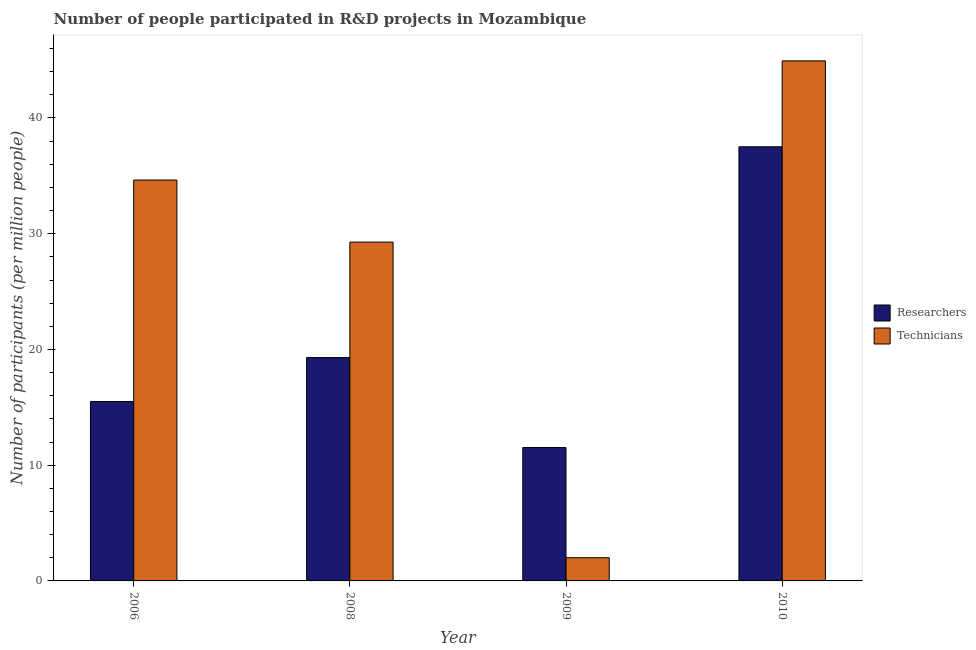How many groups of bars are there?
Offer a very short reply. 4. How many bars are there on the 4th tick from the left?
Ensure brevity in your answer.  2. How many bars are there on the 1st tick from the right?
Your answer should be very brief. 2. In how many cases, is the number of bars for a given year not equal to the number of legend labels?
Your answer should be very brief. 0. What is the number of researchers in 2009?
Offer a terse response. 11.53. Across all years, what is the maximum number of researchers?
Offer a very short reply. 37.51. Across all years, what is the minimum number of researchers?
Make the answer very short. 11.53. In which year was the number of technicians minimum?
Provide a short and direct response. 2009. What is the total number of researchers in the graph?
Ensure brevity in your answer.  83.84. What is the difference between the number of technicians in 2008 and that in 2010?
Give a very brief answer. -15.66. What is the difference between the number of technicians in 2010 and the number of researchers in 2009?
Provide a short and direct response. 42.93. What is the average number of technicians per year?
Your response must be concise. 27.71. In how many years, is the number of technicians greater than 30?
Your answer should be compact. 2. What is the ratio of the number of technicians in 2006 to that in 2008?
Your answer should be compact. 1.18. Is the difference between the number of researchers in 2009 and 2010 greater than the difference between the number of technicians in 2009 and 2010?
Provide a short and direct response. No. What is the difference between the highest and the second highest number of technicians?
Provide a succinct answer. 10.29. What is the difference between the highest and the lowest number of researchers?
Give a very brief answer. 25.99. In how many years, is the number of researchers greater than the average number of researchers taken over all years?
Your answer should be very brief. 1. What does the 2nd bar from the left in 2009 represents?
Give a very brief answer. Technicians. What does the 1st bar from the right in 2010 represents?
Keep it short and to the point. Technicians. How many years are there in the graph?
Offer a terse response. 4. What is the difference between two consecutive major ticks on the Y-axis?
Keep it short and to the point. 10. Does the graph contain grids?
Provide a short and direct response. No. How many legend labels are there?
Give a very brief answer. 2. How are the legend labels stacked?
Your answer should be very brief. Vertical. What is the title of the graph?
Provide a succinct answer. Number of people participated in R&D projects in Mozambique. Does "Secondary Education" appear as one of the legend labels in the graph?
Offer a terse response. No. What is the label or title of the X-axis?
Provide a short and direct response. Year. What is the label or title of the Y-axis?
Your answer should be compact. Number of participants (per million people). What is the Number of participants (per million people) in Researchers in 2006?
Your response must be concise. 15.5. What is the Number of participants (per million people) of Technicians in 2006?
Your response must be concise. 34.64. What is the Number of participants (per million people) in Researchers in 2008?
Provide a short and direct response. 19.3. What is the Number of participants (per million people) in Technicians in 2008?
Your response must be concise. 29.28. What is the Number of participants (per million people) of Researchers in 2009?
Ensure brevity in your answer.  11.53. What is the Number of participants (per million people) of Technicians in 2009?
Ensure brevity in your answer.  2.01. What is the Number of participants (per million people) of Researchers in 2010?
Make the answer very short. 37.51. What is the Number of participants (per million people) of Technicians in 2010?
Ensure brevity in your answer.  44.93. Across all years, what is the maximum Number of participants (per million people) of Researchers?
Offer a very short reply. 37.51. Across all years, what is the maximum Number of participants (per million people) in Technicians?
Keep it short and to the point. 44.93. Across all years, what is the minimum Number of participants (per million people) of Researchers?
Ensure brevity in your answer.  11.53. Across all years, what is the minimum Number of participants (per million people) in Technicians?
Your answer should be compact. 2.01. What is the total Number of participants (per million people) in Researchers in the graph?
Offer a very short reply. 83.84. What is the total Number of participants (per million people) of Technicians in the graph?
Provide a short and direct response. 110.86. What is the difference between the Number of participants (per million people) in Researchers in 2006 and that in 2008?
Provide a succinct answer. -3.8. What is the difference between the Number of participants (per million people) in Technicians in 2006 and that in 2008?
Keep it short and to the point. 5.36. What is the difference between the Number of participants (per million people) of Researchers in 2006 and that in 2009?
Your answer should be compact. 3.98. What is the difference between the Number of participants (per million people) in Technicians in 2006 and that in 2009?
Make the answer very short. 32.63. What is the difference between the Number of participants (per million people) of Researchers in 2006 and that in 2010?
Offer a terse response. -22.01. What is the difference between the Number of participants (per million people) in Technicians in 2006 and that in 2010?
Your answer should be compact. -10.29. What is the difference between the Number of participants (per million people) of Researchers in 2008 and that in 2009?
Keep it short and to the point. 7.77. What is the difference between the Number of participants (per million people) in Technicians in 2008 and that in 2009?
Your answer should be compact. 27.27. What is the difference between the Number of participants (per million people) in Researchers in 2008 and that in 2010?
Ensure brevity in your answer.  -18.21. What is the difference between the Number of participants (per million people) of Technicians in 2008 and that in 2010?
Give a very brief answer. -15.66. What is the difference between the Number of participants (per million people) of Researchers in 2009 and that in 2010?
Offer a very short reply. -25.99. What is the difference between the Number of participants (per million people) of Technicians in 2009 and that in 2010?
Provide a succinct answer. -42.93. What is the difference between the Number of participants (per million people) in Researchers in 2006 and the Number of participants (per million people) in Technicians in 2008?
Your response must be concise. -13.77. What is the difference between the Number of participants (per million people) of Researchers in 2006 and the Number of participants (per million people) of Technicians in 2009?
Provide a succinct answer. 13.5. What is the difference between the Number of participants (per million people) of Researchers in 2006 and the Number of participants (per million people) of Technicians in 2010?
Your answer should be very brief. -29.43. What is the difference between the Number of participants (per million people) of Researchers in 2008 and the Number of participants (per million people) of Technicians in 2009?
Make the answer very short. 17.29. What is the difference between the Number of participants (per million people) in Researchers in 2008 and the Number of participants (per million people) in Technicians in 2010?
Make the answer very short. -25.63. What is the difference between the Number of participants (per million people) of Researchers in 2009 and the Number of participants (per million people) of Technicians in 2010?
Keep it short and to the point. -33.41. What is the average Number of participants (per million people) in Researchers per year?
Offer a very short reply. 20.96. What is the average Number of participants (per million people) of Technicians per year?
Give a very brief answer. 27.71. In the year 2006, what is the difference between the Number of participants (per million people) in Researchers and Number of participants (per million people) in Technicians?
Keep it short and to the point. -19.14. In the year 2008, what is the difference between the Number of participants (per million people) in Researchers and Number of participants (per million people) in Technicians?
Give a very brief answer. -9.98. In the year 2009, what is the difference between the Number of participants (per million people) of Researchers and Number of participants (per million people) of Technicians?
Your answer should be compact. 9.52. In the year 2010, what is the difference between the Number of participants (per million people) of Researchers and Number of participants (per million people) of Technicians?
Your answer should be very brief. -7.42. What is the ratio of the Number of participants (per million people) of Researchers in 2006 to that in 2008?
Your response must be concise. 0.8. What is the ratio of the Number of participants (per million people) of Technicians in 2006 to that in 2008?
Your response must be concise. 1.18. What is the ratio of the Number of participants (per million people) in Researchers in 2006 to that in 2009?
Keep it short and to the point. 1.34. What is the ratio of the Number of participants (per million people) of Technicians in 2006 to that in 2009?
Your response must be concise. 17.27. What is the ratio of the Number of participants (per million people) in Researchers in 2006 to that in 2010?
Give a very brief answer. 0.41. What is the ratio of the Number of participants (per million people) of Technicians in 2006 to that in 2010?
Offer a very short reply. 0.77. What is the ratio of the Number of participants (per million people) in Researchers in 2008 to that in 2009?
Provide a short and direct response. 1.67. What is the ratio of the Number of participants (per million people) in Technicians in 2008 to that in 2009?
Ensure brevity in your answer.  14.59. What is the ratio of the Number of participants (per million people) of Researchers in 2008 to that in 2010?
Ensure brevity in your answer.  0.51. What is the ratio of the Number of participants (per million people) in Technicians in 2008 to that in 2010?
Ensure brevity in your answer.  0.65. What is the ratio of the Number of participants (per million people) of Researchers in 2009 to that in 2010?
Provide a short and direct response. 0.31. What is the ratio of the Number of participants (per million people) of Technicians in 2009 to that in 2010?
Give a very brief answer. 0.04. What is the difference between the highest and the second highest Number of participants (per million people) in Researchers?
Offer a very short reply. 18.21. What is the difference between the highest and the second highest Number of participants (per million people) in Technicians?
Keep it short and to the point. 10.29. What is the difference between the highest and the lowest Number of participants (per million people) in Researchers?
Your response must be concise. 25.99. What is the difference between the highest and the lowest Number of participants (per million people) in Technicians?
Your answer should be very brief. 42.93. 